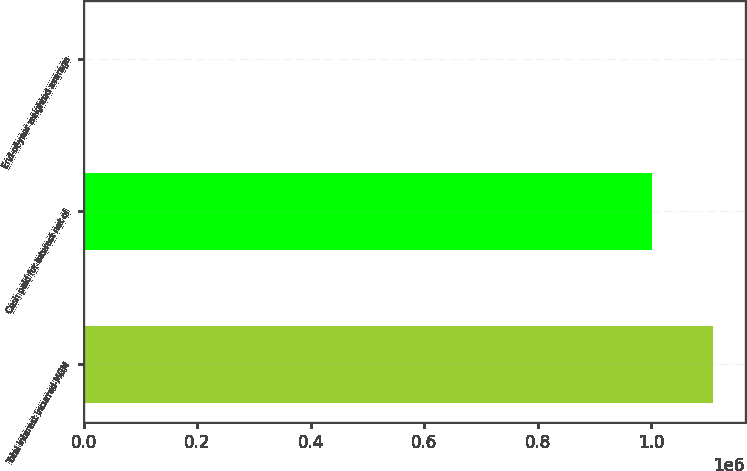<chart> <loc_0><loc_0><loc_500><loc_500><bar_chart><fcel>Total interest incurred-MGM<fcel>Cash paid for interest net of<fcel>End-of-year weighted average<nl><fcel>1.10938e+06<fcel>1.00198e+06<fcel>7.7<nl></chart> 